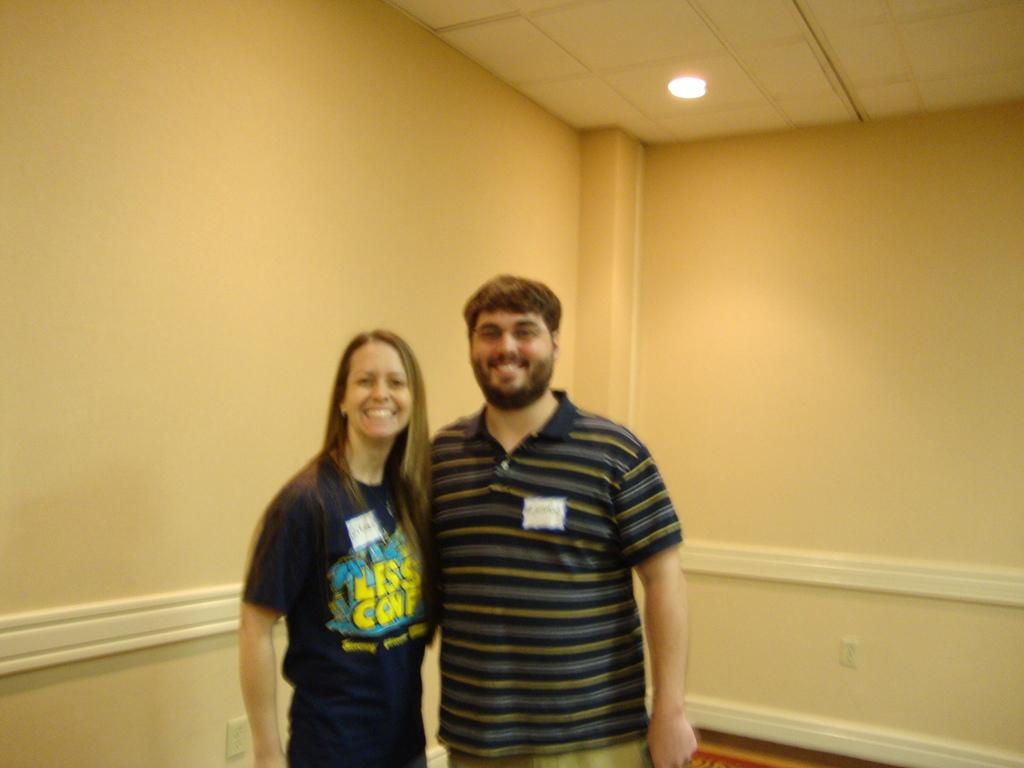How many people are in the image? There are two persons in the image. What type of surface is visible in the image? There is ground visible in the image. What can be found on the wall in the image? There is a wall with switch boards in the image. What is present on the roof in the image? There is a roof with lights in the image. What type of fuel is being used by the dock in the image? There is no dock present in the image, so there is no fuel being used. 